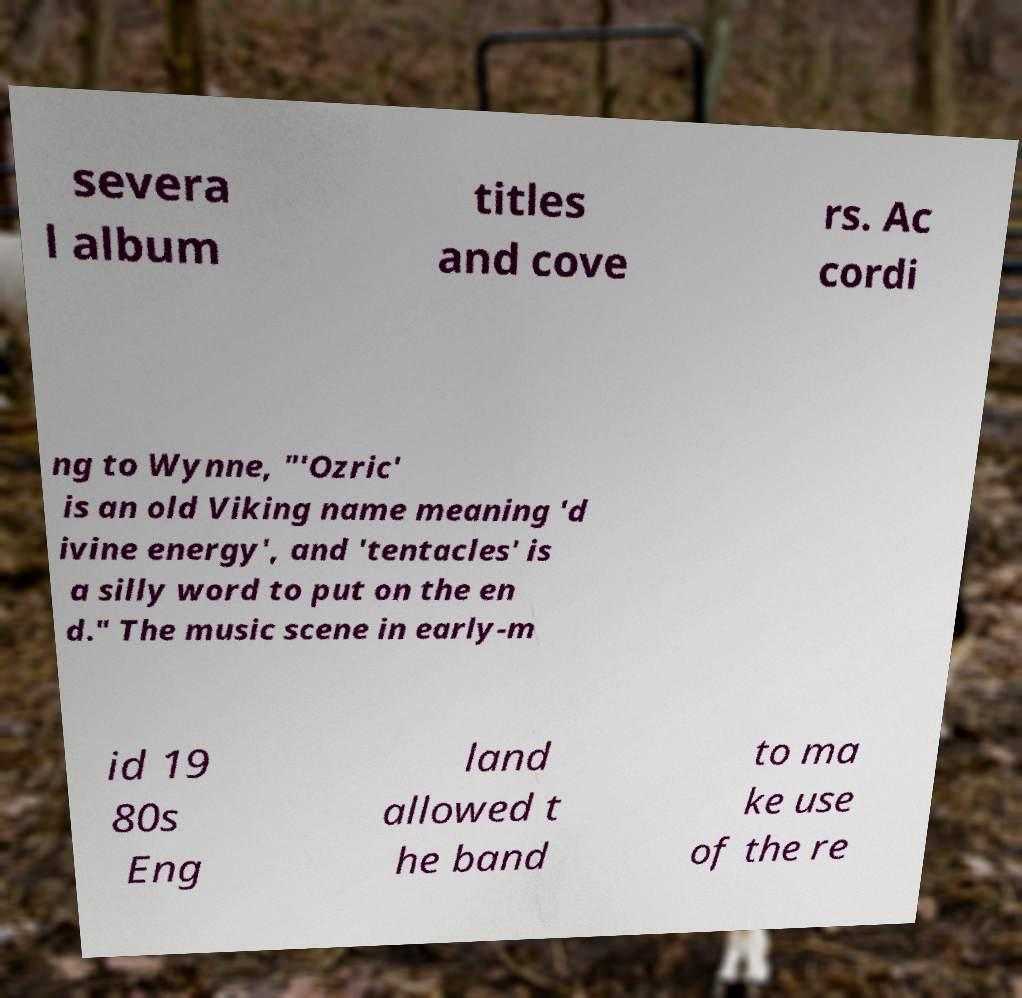There's text embedded in this image that I need extracted. Can you transcribe it verbatim? severa l album titles and cove rs. Ac cordi ng to Wynne, "'Ozric' is an old Viking name meaning 'd ivine energy', and 'tentacles' is a silly word to put on the en d." The music scene in early-m id 19 80s Eng land allowed t he band to ma ke use of the re 